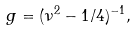<formula> <loc_0><loc_0><loc_500><loc_500>g = ( \nu ^ { 2 } - 1 / 4 ) ^ { - 1 } ,</formula> 